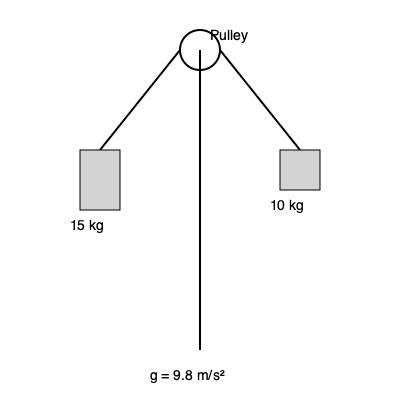In the pulley system shown above, determine the acceleration of the 15 kg mass and the tension in the rope. Assume the pulley is massless and frictionless, and the rope is inextensible. Express your answers in m/s² and N, respectively. To solve this problem, we'll use Newton's Second Law and the concept of mechanical advantage in pulley systems. Let's approach this step-by-step:

1) Let $a$ be the acceleration of the system, $T$ be the tension in the rope, and $g = 9.8$ m/s².

2) For the 15 kg mass:
   $T - 15g = 15a$ (downward acceleration is positive)

3) For the 10 kg mass:
   $T - 10g = -10a$ (upward acceleration is negative)

4) Add these equations:
   $2T - 25g = 5a$

5) Solve for $T$:
   $T = \frac{25g + 5a}{2}$

6) Substitute this into the equation for the 15 kg mass:
   $\frac{25g + 5a}{2} - 15g = 15a$

7) Simplify:
   $25g + 5a - 30g = 30a$
   $-5g = 25a$

8) Solve for $a$:
   $a = -\frac{5g}{25} = -1.96$ m/s²

9) The negative sign indicates the 15 kg mass is accelerating upward.

10) Now substitute this value of $a$ back into the equation for $T$:
    $T = \frac{25g + 5(-1.96)}{2} = 112.7$ N

Therefore, the acceleration of the 15 kg mass is 1.96 m/s² upward, and the tension in the rope is 112.7 N.
Answer: $a = 1.96$ m/s² (upward), $T = 112.7$ N 